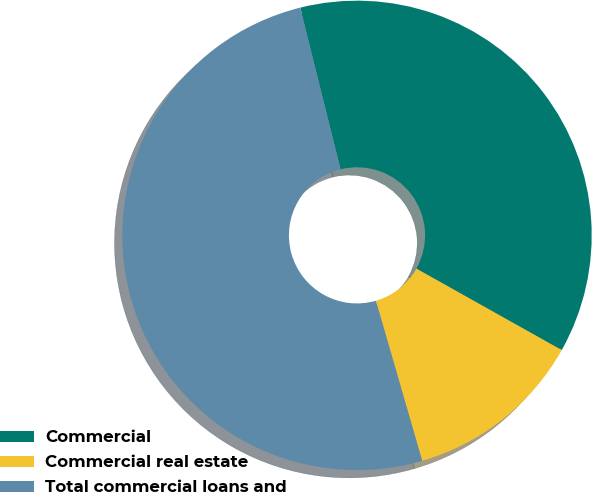Convert chart to OTSL. <chart><loc_0><loc_0><loc_500><loc_500><pie_chart><fcel>Commercial<fcel>Commercial real estate<fcel>Total commercial loans and<nl><fcel>37.02%<fcel>12.39%<fcel>50.59%<nl></chart> 